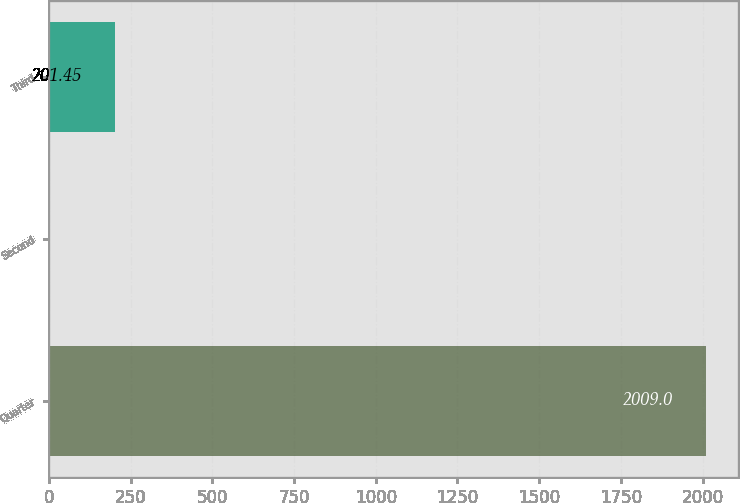Convert chart to OTSL. <chart><loc_0><loc_0><loc_500><loc_500><bar_chart><fcel>Quarter<fcel>Second<fcel>Third<nl><fcel>2009<fcel>0.61<fcel>201.45<nl></chart> 